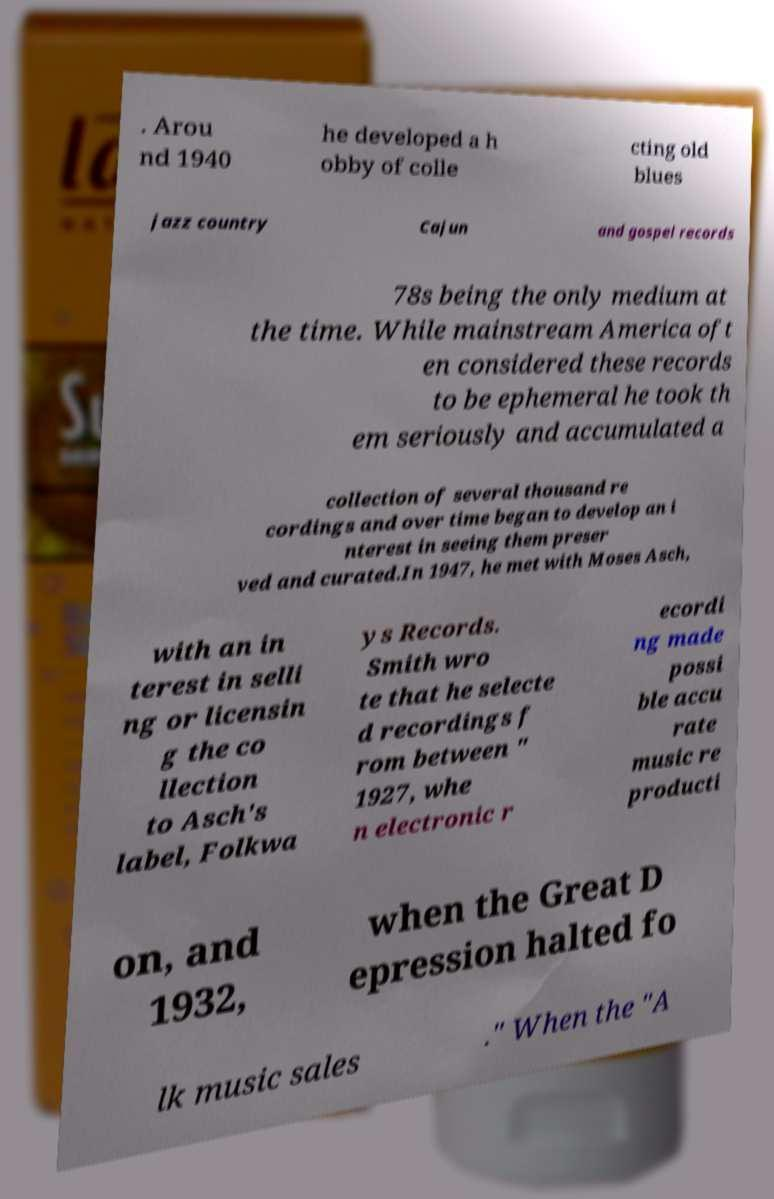Please identify and transcribe the text found in this image. . Arou nd 1940 he developed a h obby of colle cting old blues jazz country Cajun and gospel records 78s being the only medium at the time. While mainstream America oft en considered these records to be ephemeral he took th em seriously and accumulated a collection of several thousand re cordings and over time began to develop an i nterest in seeing them preser ved and curated.In 1947, he met with Moses Asch, with an in terest in selli ng or licensin g the co llection to Asch's label, Folkwa ys Records. Smith wro te that he selecte d recordings f rom between " 1927, whe n electronic r ecordi ng made possi ble accu rate music re producti on, and 1932, when the Great D epression halted fo lk music sales ." When the "A 